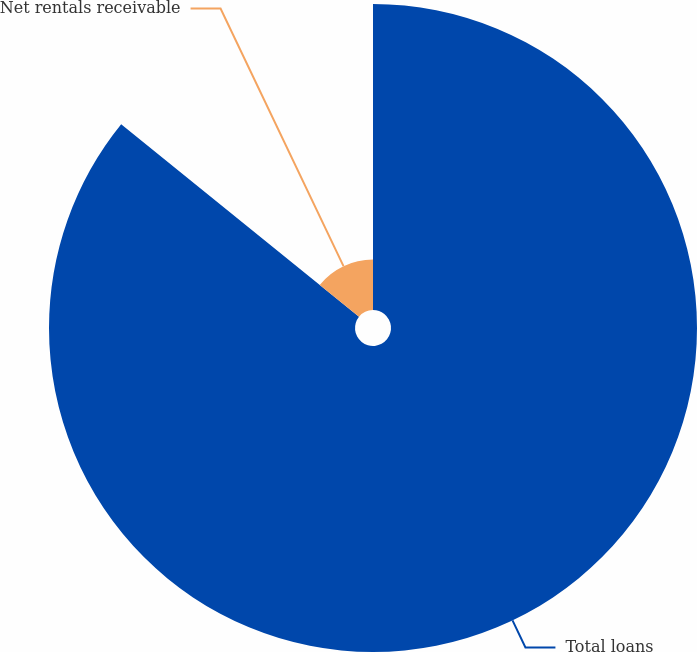Convert chart. <chart><loc_0><loc_0><loc_500><loc_500><pie_chart><fcel>Total loans<fcel>Net rentals receivable<nl><fcel>85.83%<fcel>14.17%<nl></chart> 